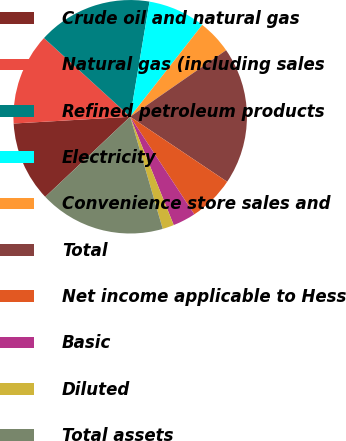Convert chart to OTSL. <chart><loc_0><loc_0><loc_500><loc_500><pie_chart><fcel>Crude oil and natural gas<fcel>Natural gas (including sales<fcel>Refined petroleum products<fcel>Electricity<fcel>Convenience store sales and<fcel>Total<fcel>Net income applicable to Hess<fcel>Basic<fcel>Diluted<fcel>Total assets<nl><fcel>11.11%<fcel>12.7%<fcel>15.87%<fcel>7.94%<fcel>4.76%<fcel>19.05%<fcel>6.35%<fcel>3.17%<fcel>1.59%<fcel>17.46%<nl></chart> 